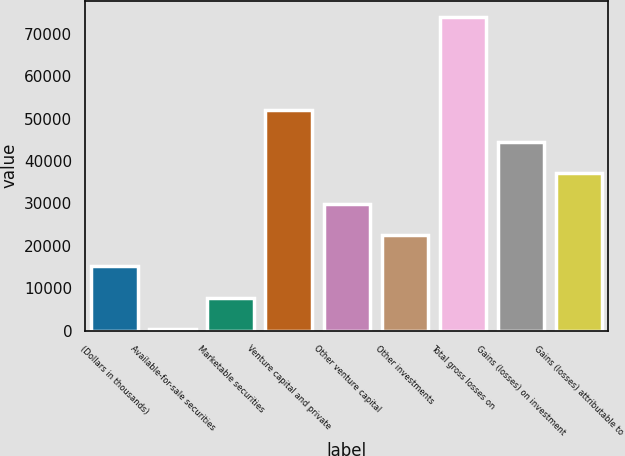Convert chart to OTSL. <chart><loc_0><loc_0><loc_500><loc_500><bar_chart><fcel>(Dollars in thousands)<fcel>Available-for-sale securities<fcel>Marketable securities<fcel>Venture capital and private<fcel>Other venture capital<fcel>Other investments<fcel>Total gross losses on<fcel>Gains (losses) on investment<fcel>Gains (losses) attributable to<nl><fcel>15136.2<fcel>414<fcel>7775.1<fcel>51941.7<fcel>29858.4<fcel>22497.3<fcel>74025<fcel>44580.6<fcel>37219.5<nl></chart> 